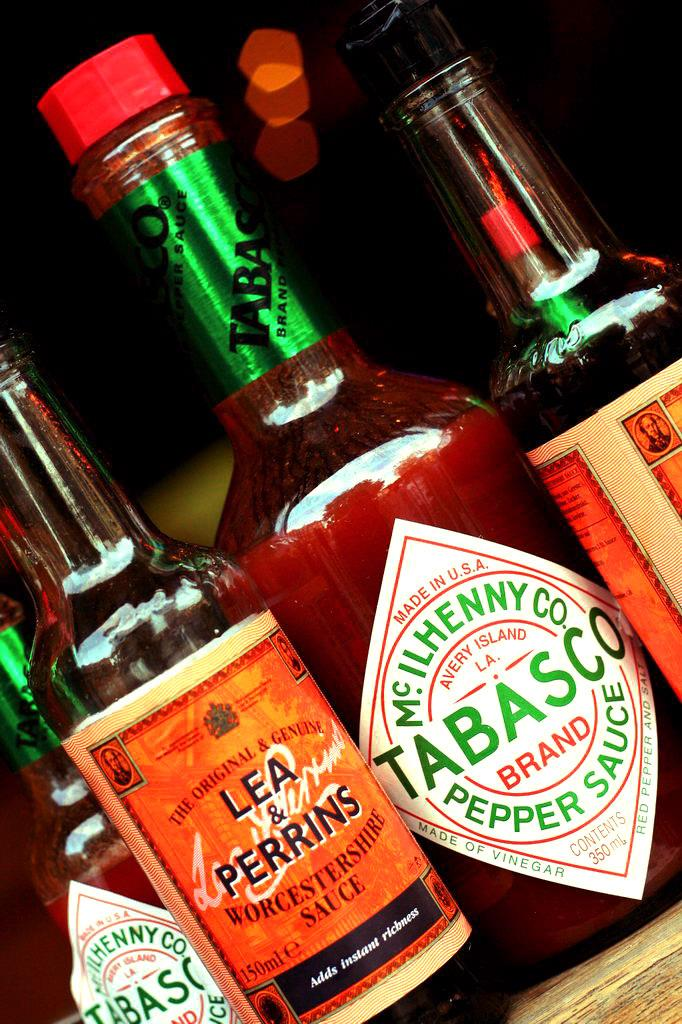<image>
Offer a succinct explanation of the picture presented. A bottle of Tabasco sits among other condiments. 